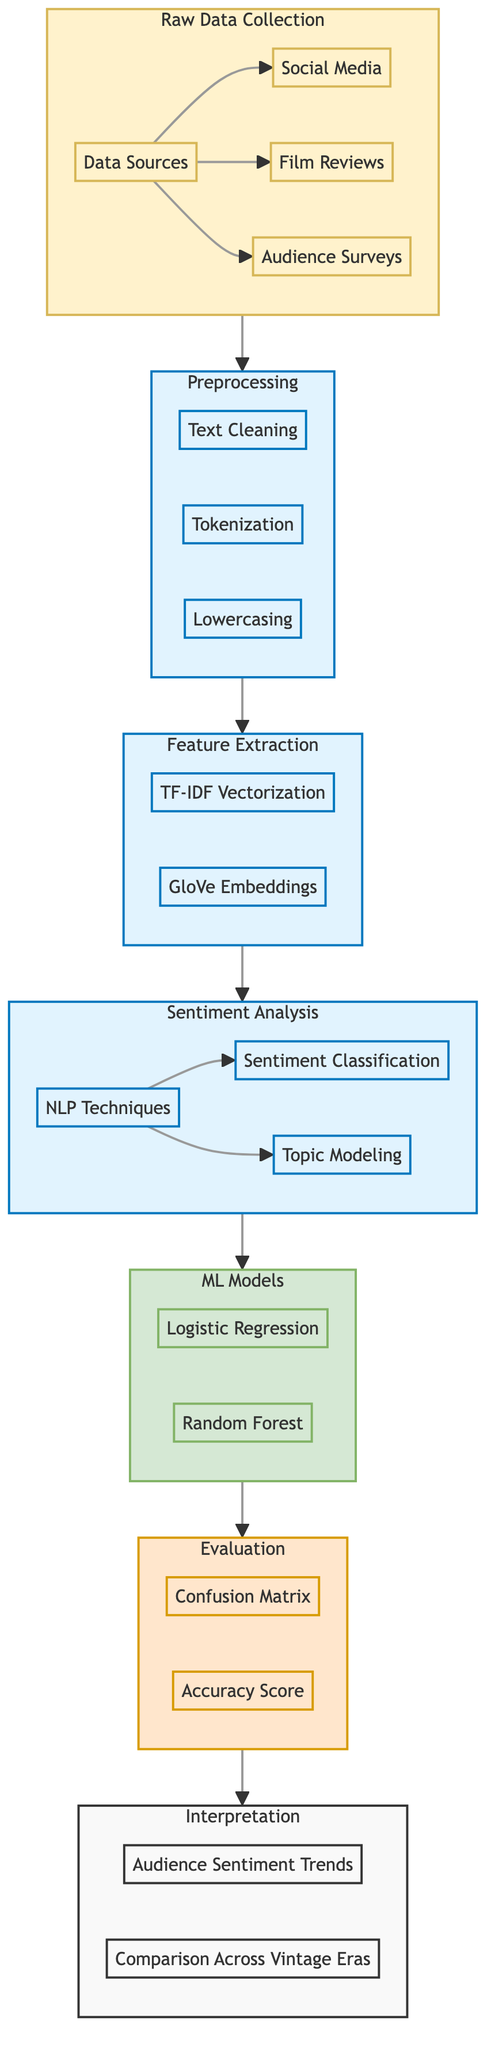What are the three data sources in the Raw Data Collection? The diagram explicitly lists three data sources within the Raw Data Collection subgraph: Social Media, Film Reviews, and Audience Surveys.
Answer: Social Media, Film Reviews, Audience Surveys How many processes are involved in Preprocessing? The Preprocessing subgraph contains three distinct processes: Text Cleaning, Tokenization, and Lowercasing, indicating that there are three processes in total.
Answer: Three Which machine learning model is listed first in the Models section? The diagram shows Logistic Regression as the first model in the ML Models subgraph before Random Forest. By observing the order, we can confirm this.
Answer: Logistic Regression What nodes lead into the Sentiment Analysis section? The diagram indicates that the output from the Feature Extraction subgraph is directed into the Sentiment Analysis subgraph, which is confirmed by the connecting arrows.
Answer: Feature Extraction Which evaluation metric is shown alongside the Confusion Matrix in the Evaluation section? The two evaluation metrics shown in the Evaluation subgraph are Confusion Matrix and Accuracy Score. Therefore, Accuracy Score is the one that pairs with Confusion Matrix.
Answer: Accuracy Score What is the final stage of the diagram after Evaluation? The diagram presents Interpretation as the final stage responsible for displaying the outputs and insights derived from the Evaluation process. This can be recognized as the end of the flow.
Answer: Interpretation How many main processes are identified in the diagram? By summing the distinct processes arranged in the subgraphs, we find Preprocessing, Sentiment Analysis, Feature Extraction, and the ML Models, which constitutes four main processes in total.
Answer: Four Which subgraph directly follows Feature Extraction in the flow? According to the flow direction indicated by the arrows in the diagram, Sentiment Analysis directly follows Feature Extraction, demonstrating the order of operations in the analysis process.
Answer: Sentiment Analysis 